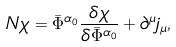<formula> <loc_0><loc_0><loc_500><loc_500>N \chi = \bar { \Phi } ^ { \alpha _ { 0 } } \frac { \delta \chi } { \delta \bar { \Phi } ^ { \alpha _ { 0 } } } + \partial ^ { \mu } j _ { \mu } ,</formula> 